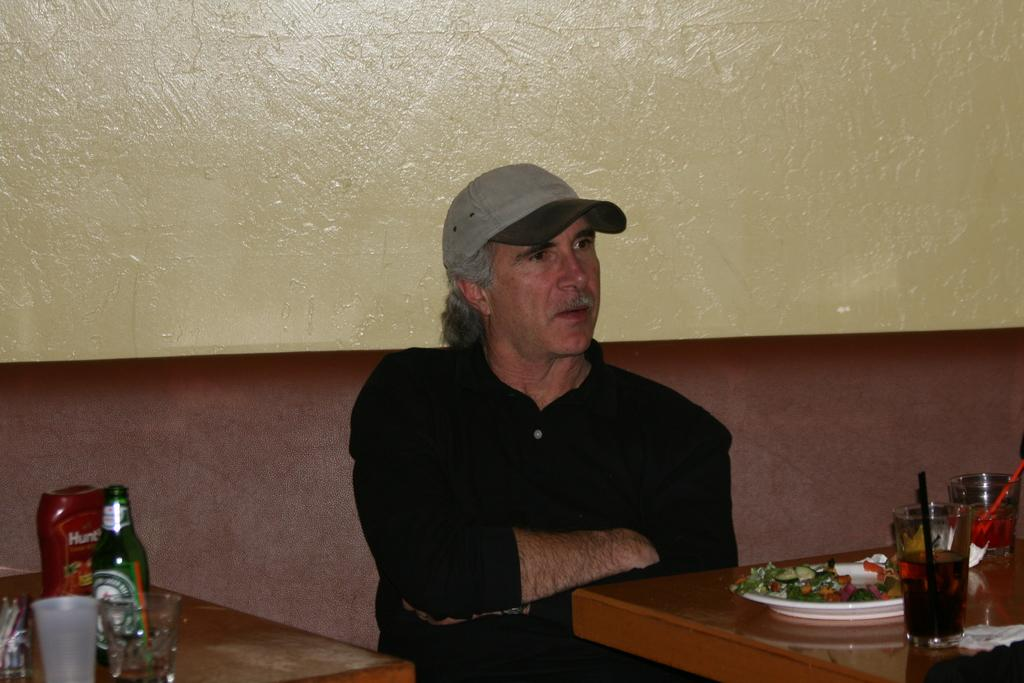<image>
Share a concise interpretation of the image provided. A man sits at a booth in a restaurant. 